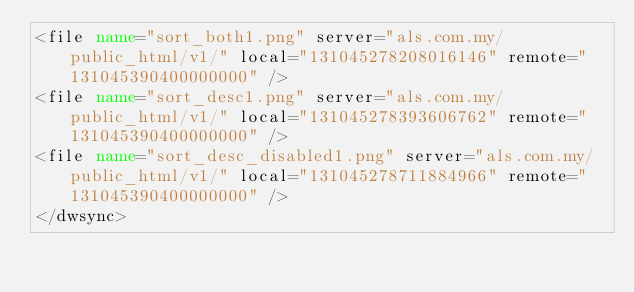<code> <loc_0><loc_0><loc_500><loc_500><_XML_><file name="sort_both1.png" server="als.com.my/public_html/v1/" local="131045278208016146" remote="131045390400000000" />
<file name="sort_desc1.png" server="als.com.my/public_html/v1/" local="131045278393606762" remote="131045390400000000" />
<file name="sort_desc_disabled1.png" server="als.com.my/public_html/v1/" local="131045278711884966" remote="131045390400000000" />
</dwsync></code> 